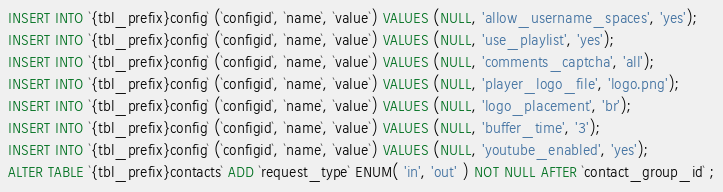Convert code to text. <code><loc_0><loc_0><loc_500><loc_500><_SQL_>INSERT INTO `{tbl_prefix}config` (`configid`, `name`, `value`) VALUES (NULL, 'allow_username_spaces', 'yes');
INSERT INTO `{tbl_prefix}config` (`configid`, `name`, `value`) VALUES (NULL, 'use_playlist', 'yes');
INSERT INTO `{tbl_prefix}config` (`configid`, `name`, `value`) VALUES (NULL, 'comments_captcha', 'all');
INSERT INTO `{tbl_prefix}config` (`configid`, `name`, `value`) VALUES (NULL, 'player_logo_file', 'logo.png');
INSERT INTO `{tbl_prefix}config` (`configid`, `name`, `value`) VALUES (NULL, 'logo_placement', 'br');
INSERT INTO `{tbl_prefix}config` (`configid`, `name`, `value`) VALUES (NULL, 'buffer_time', '3');
INSERT INTO `{tbl_prefix}config` (`configid`, `name`, `value`) VALUES (NULL, 'youtube_enabled', 'yes');
ALTER TABLE `{tbl_prefix}contacts` ADD `request_type` ENUM( 'in', 'out' ) NOT NULL AFTER `contact_group_id` ;</code> 